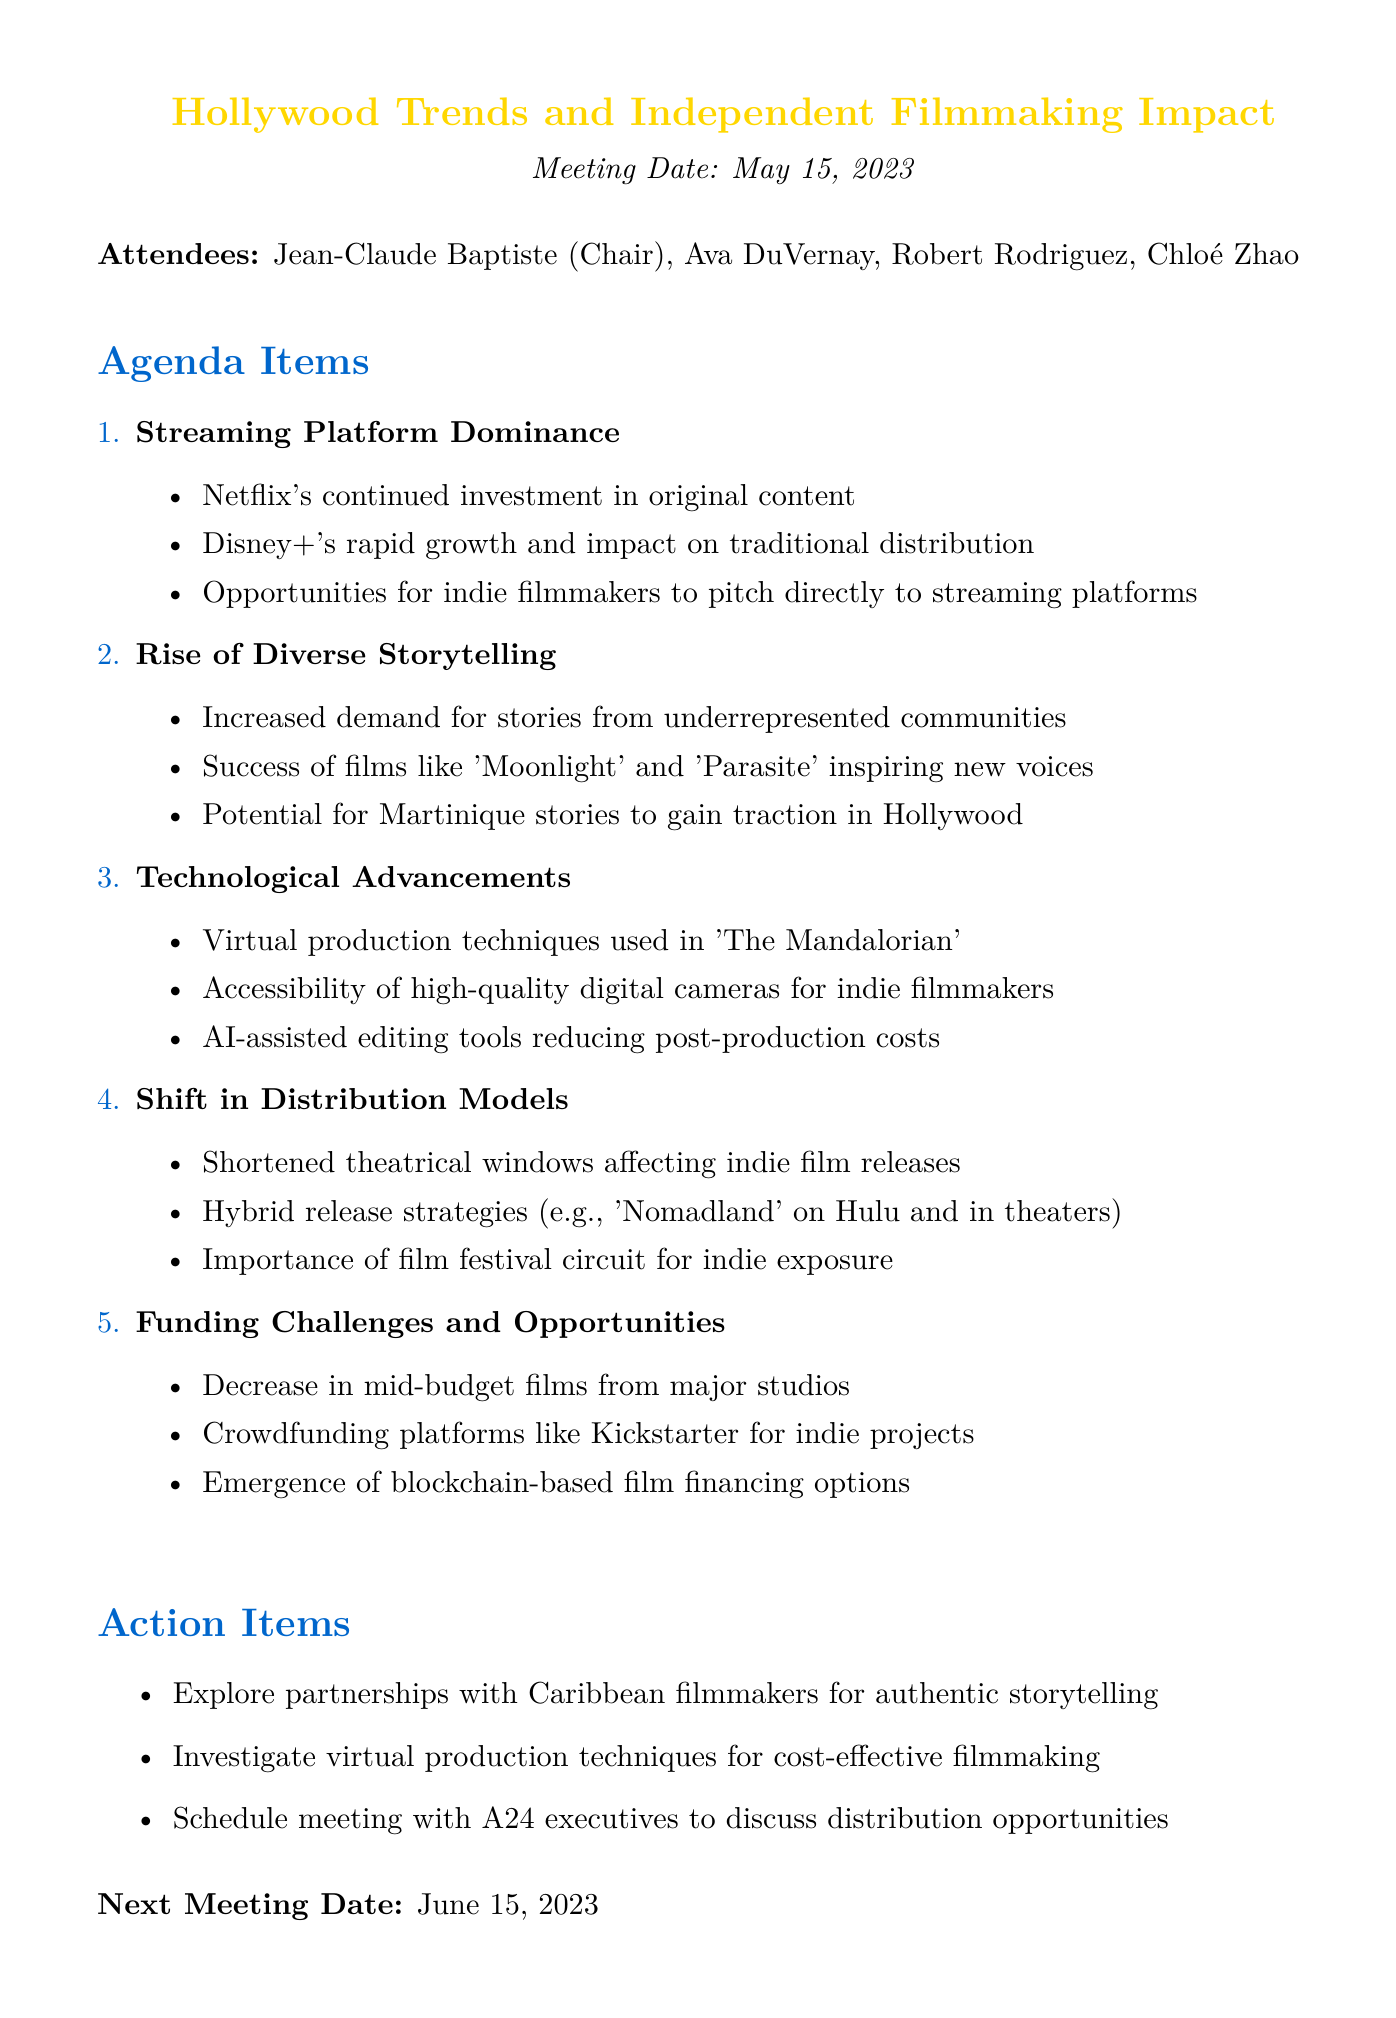What is the meeting date? The meeting date is explicitly stated in the document as May 15, 2023.
Answer: May 15, 2023 Who was the chair of the meeting? The document lists Jean-Claude Baptiste as the chair in the attendees section.
Answer: Jean-Claude Baptiste What are the key points of the "Rise of Diverse Storytelling"? The document provides specific key points under this topic, focusing on increased demand for diverse stories, success of certain films, and potential for Martinique stories.
Answer: Increased demand for stories from underrepresented communities What is one action item discussed in the meeting? The document lists several action items at the end, highlighting specific initiatives.
Answer: Explore partnerships with Caribbean filmmakers for authentic storytelling What is the date of the next meeting? The next meeting date is clearly mentioned as June 15, 2023.
Answer: June 15, 2023 What technological advancement is mentioned in relation to 'The Mandalorian'? The document highlights virtual production techniques specifically used in the show.
Answer: Virtual production techniques What trend is impacting independent filmmakers regarding distribution models? The document discusses the shift in distribution models and its effect on indie films, particularly mentioning shortened theatrical windows.
Answer: Shortened theatrical windows What funding challenges are highlighted for independent filmmakers? The meeting minutes indicate a decrease in mid-budget films from major studios as a challenge faced by indie filmmakers.
Answer: Decrease in mid-budget films from major studios 